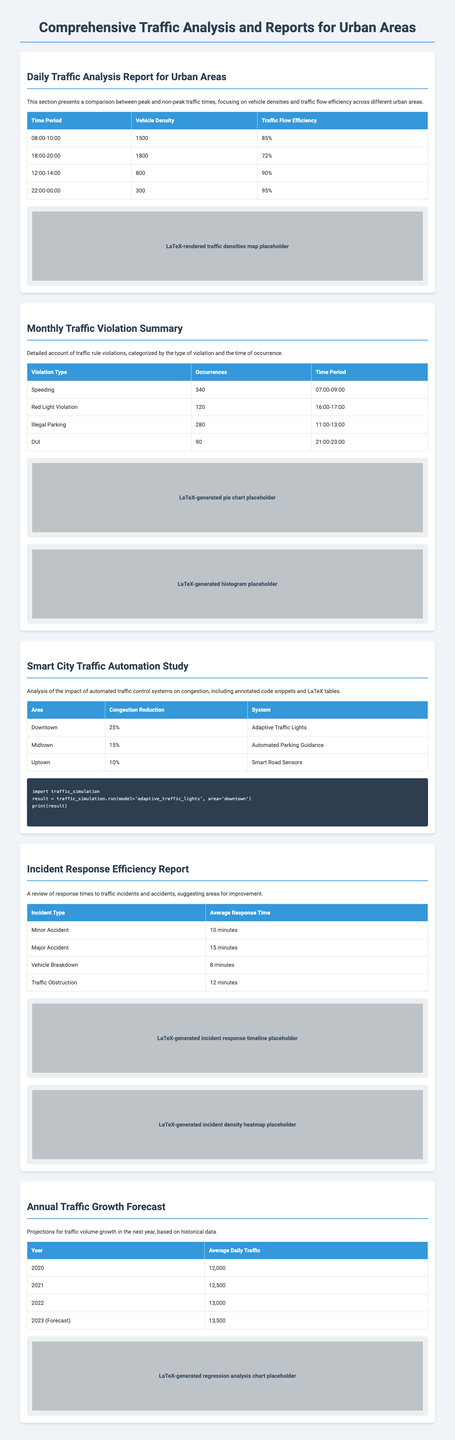What was the vehicle density during peak time from 18:00 to 20:00? The vehicle density during this peak time is stated in the Daily Traffic Analysis Report, which is 1800.
Answer: 1800 How many occurrences were there for speeding violations? The number of occurrences for speeding listed in the Monthly Traffic Violation Summary is 340.
Answer: 340 What is the average response time for major accidents? The average response time for major accidents is provided in the Incident Response Efficiency Report, which is 15 minutes.
Answer: 15 minutes What percentage of congestion reduction was observed in downtown due to automated traffic control? The congestion reduction percentage for downtown is specified in the Smart City Traffic Automation Study, which is 25%.
Answer: 25% What is the projected average daily traffic for 2023? The forecasted average daily traffic for 2023 is mentioned in the Annual Traffic Growth Forecast, which is 13,500.
Answer: 13,500 What is the time period with the lowest vehicle density? The time period with the lowest vehicle density in the Daily Traffic Analysis Report is 22:00 to 00:00, with a density of 300.
Answer: 22:00-00:00 What chart types are used to represent traffic violations? The Monthly Traffic Violation Summary mentions pie charts and histograms as the chart types used for representation.
Answer: Pie charts and histograms How many types of violations are listed in the Monthly Traffic Violation Summary? The summary categorizes violations by type, and there are four types listed in total.
Answer: Four types 